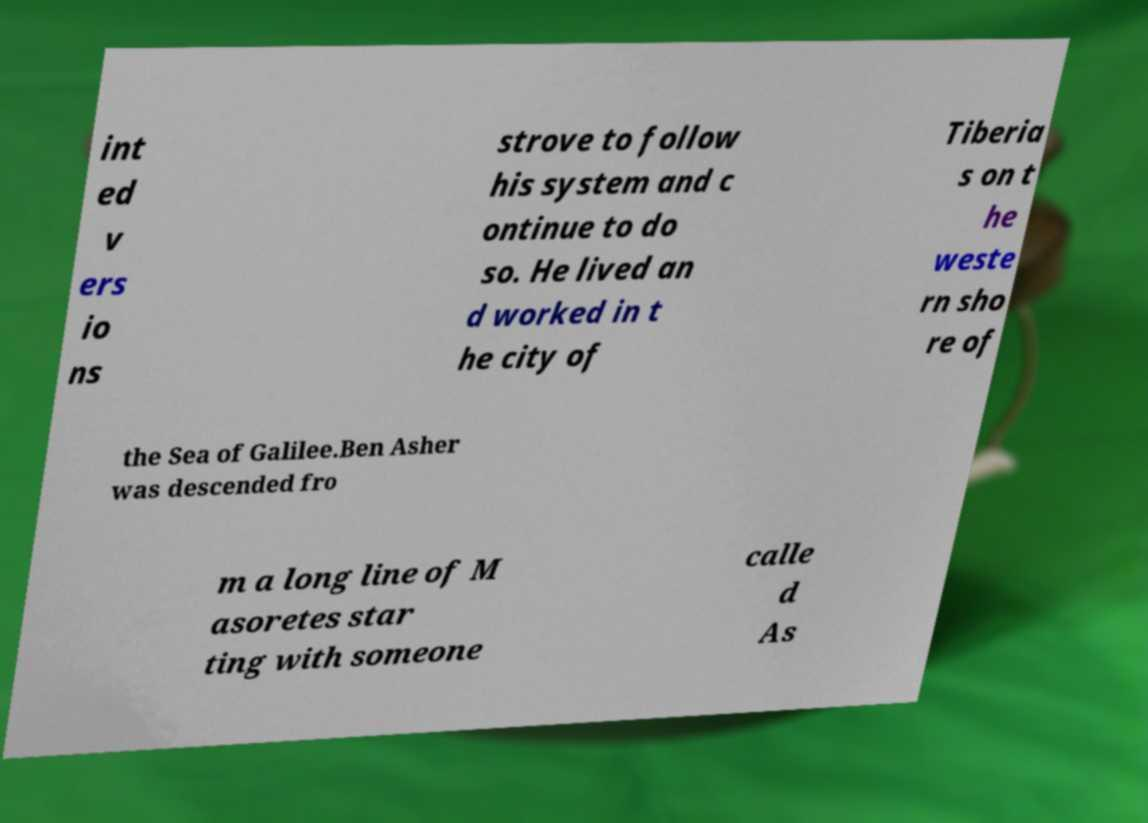Can you read and provide the text displayed in the image?This photo seems to have some interesting text. Can you extract and type it out for me? int ed v ers io ns strove to follow his system and c ontinue to do so. He lived an d worked in t he city of Tiberia s on t he weste rn sho re of the Sea of Galilee.Ben Asher was descended fro m a long line of M asoretes star ting with someone calle d As 